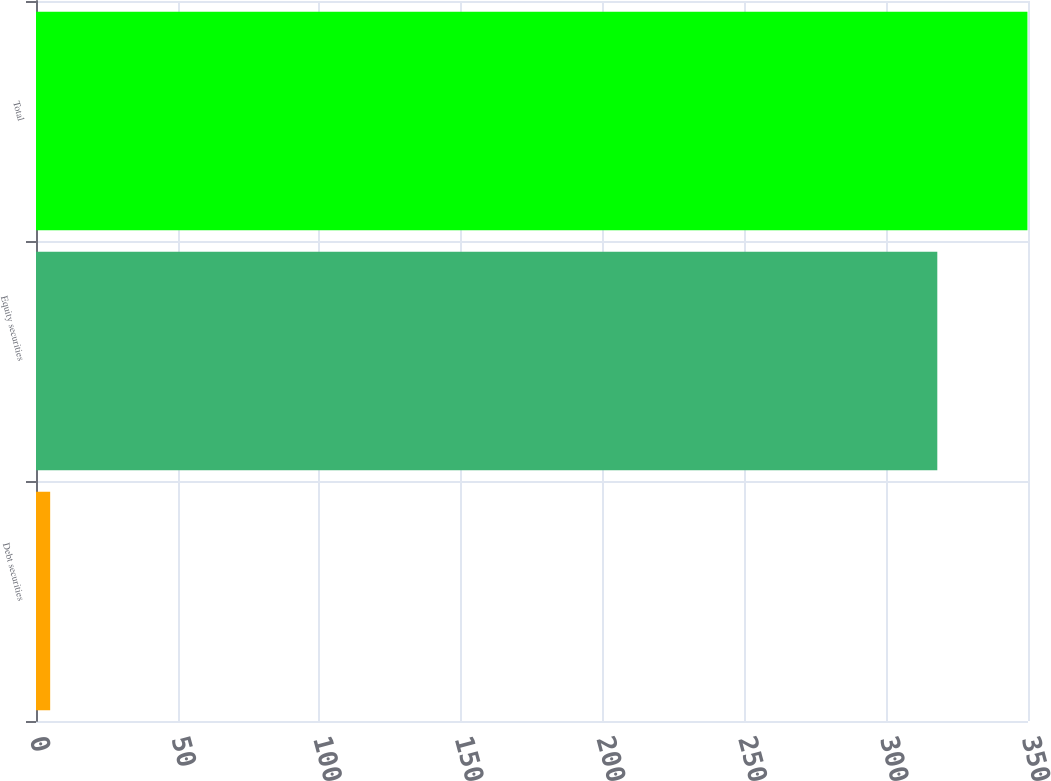<chart> <loc_0><loc_0><loc_500><loc_500><bar_chart><fcel>Debt securities<fcel>Equity securities<fcel>Total<nl><fcel>5<fcel>318<fcel>349.8<nl></chart> 